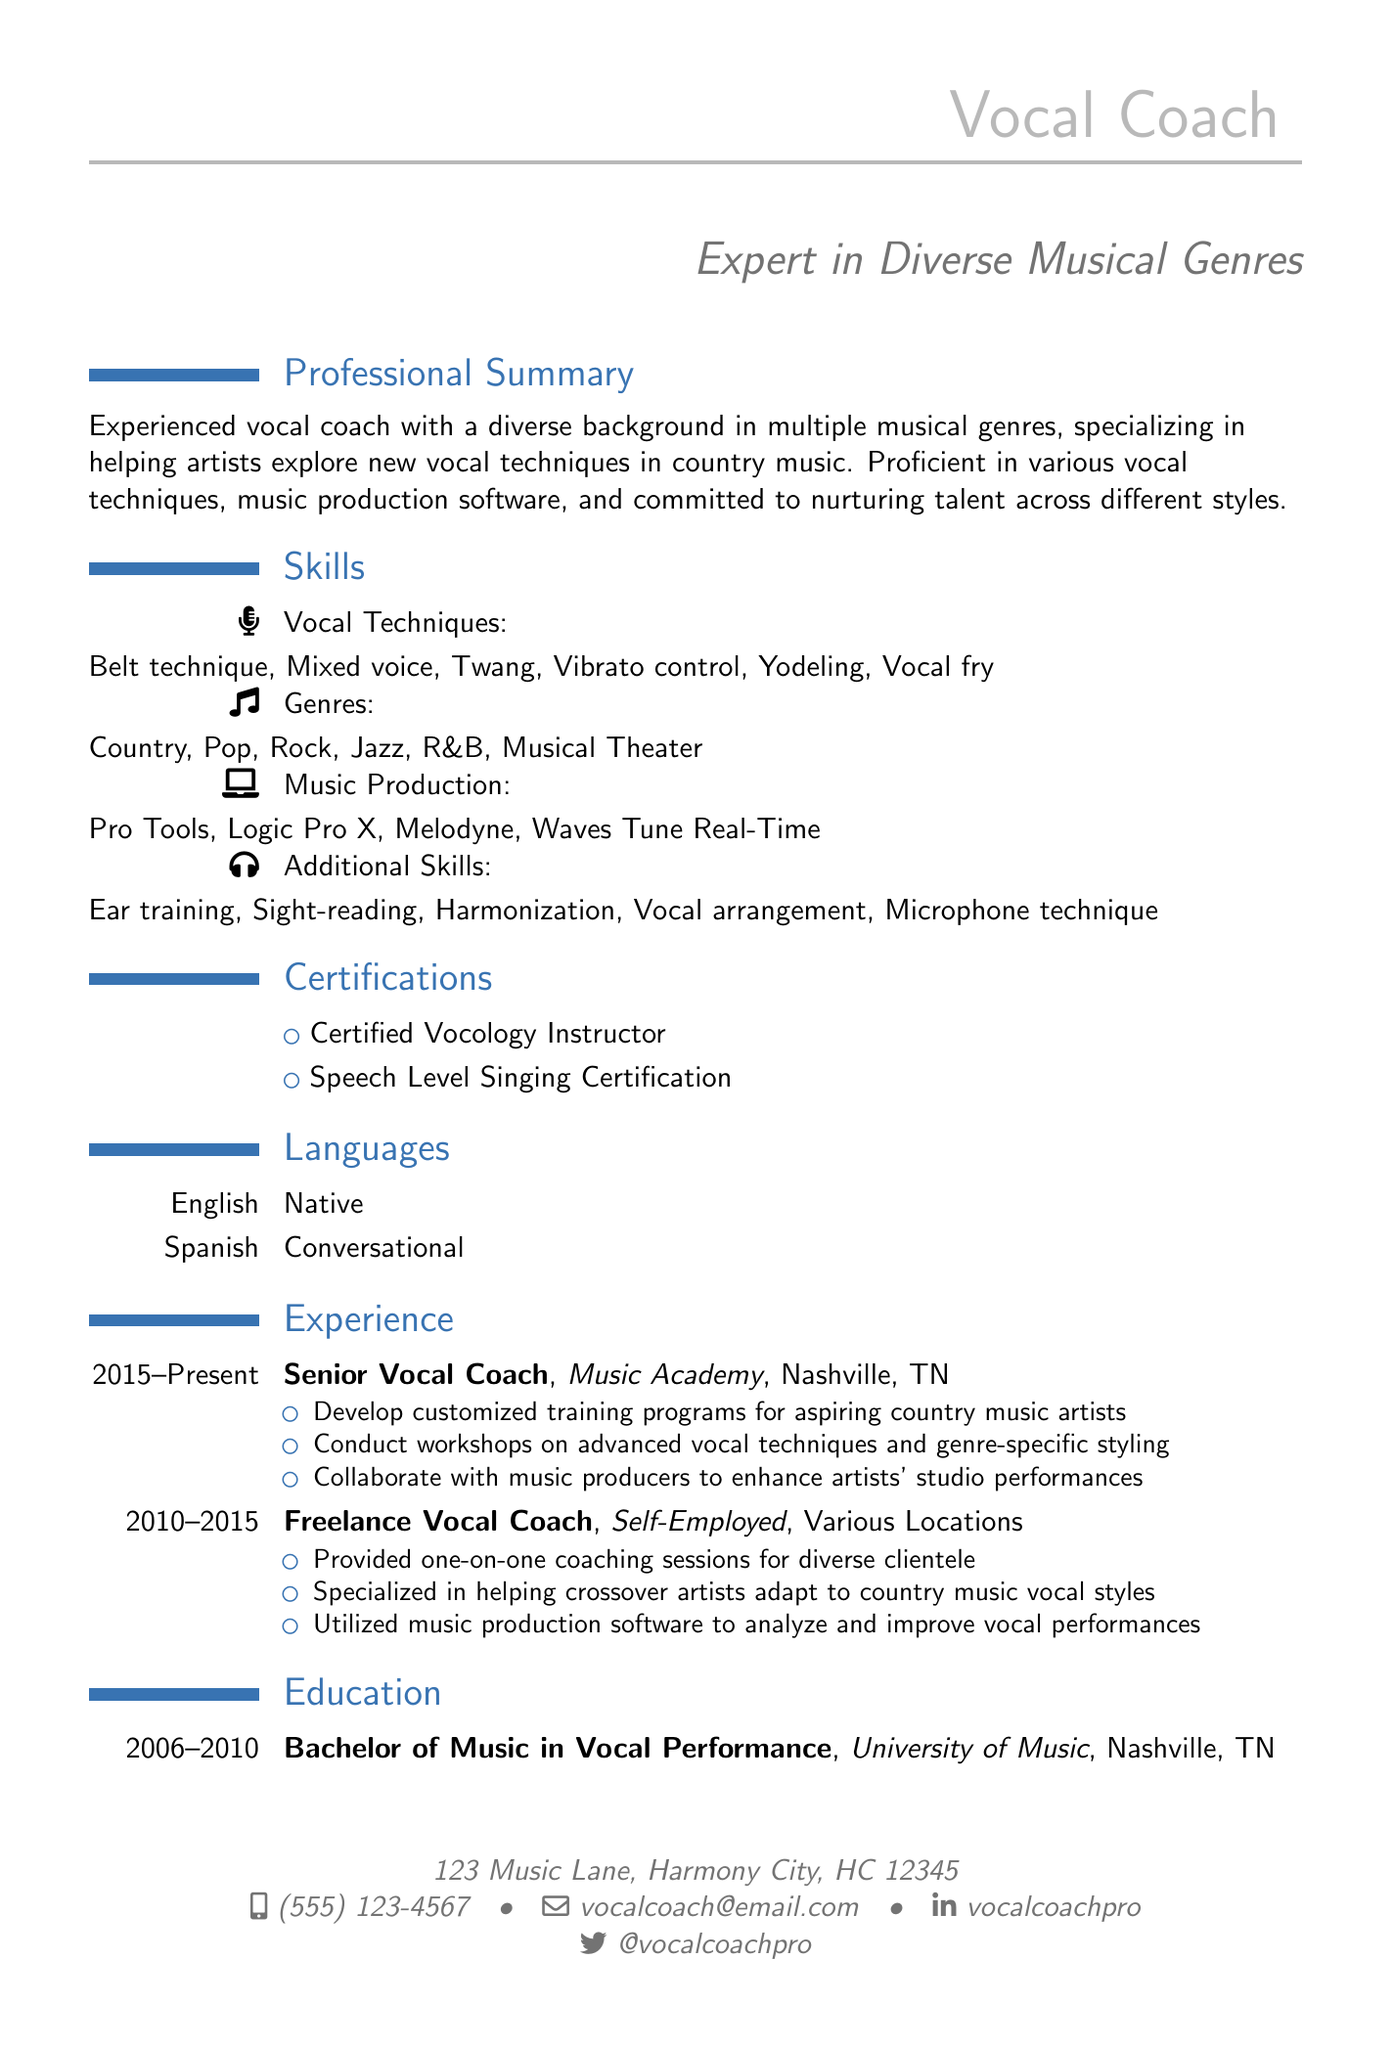what are the vocal techniques listed? The document specifies several vocal techniques in the Skills section, which include different methods used for singing.
Answer: Belt technique, Mixed voice, Twang, Vibrato control, Yodeling, Vocal fry how many genres are mentioned? The document lists multiple genres in the Skills section, reflecting the coach's versatility in different musical styles.
Answer: Six what is the name of the music production software listed? The Skills section presents specific music production software that the vocal coach is proficient in using.
Answer: Pro Tools, Logic Pro X, Melodyne, Waves Tune Real-Time what certification does the vocal coach hold? The Certifications section of the document presents training credentials obtained by the vocal coach, indicating expertise in the field.
Answer: Certified Vocology Instructor what is the location of the vocal coach's current employment? The Experience section indicates the location of the vocal coach's current position, providing context about work environment and area of expertise.
Answer: Nashville, TN which language is spoken conversationally? The Languages section includes details regarding the language proficiency of the vocal coach, showing the ability to communicate with a broader audience.
Answer: Spanish how long did the freelance vocal coach role last? The Experience section outlines the timeframe during which the vocal coach worked as a freelancer, providing insight into career trajectory.
Answer: Five years what additional skill related to vocal arrangement is mentioned? The Skills section highlights specific abilities that support the vocal coach’s training methods, including aspects of music arrangement.
Answer: Vocal arrangement 